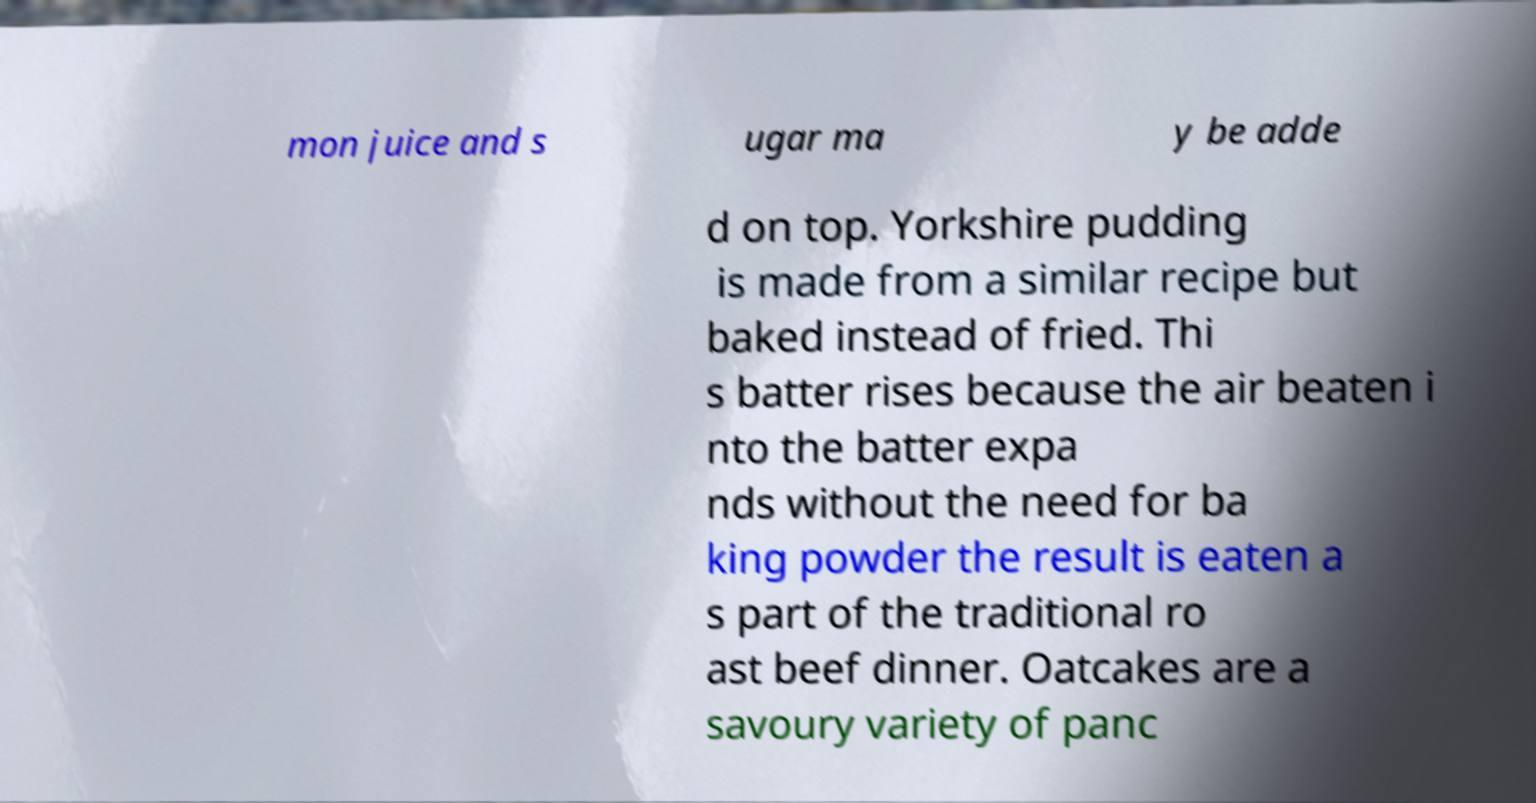There's text embedded in this image that I need extracted. Can you transcribe it verbatim? mon juice and s ugar ma y be adde d on top. Yorkshire pudding is made from a similar recipe but baked instead of fried. Thi s batter rises because the air beaten i nto the batter expa nds without the need for ba king powder the result is eaten a s part of the traditional ro ast beef dinner. Oatcakes are a savoury variety of panc 